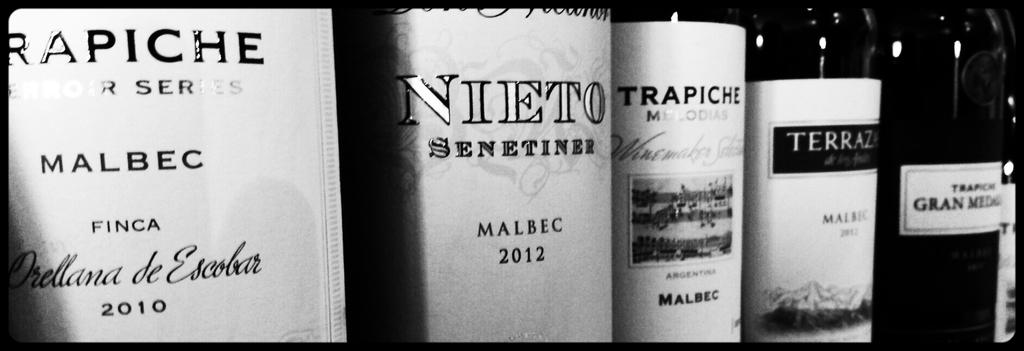<image>
Give a short and clear explanation of the subsequent image. the word Nieto that is on a wine bottle 